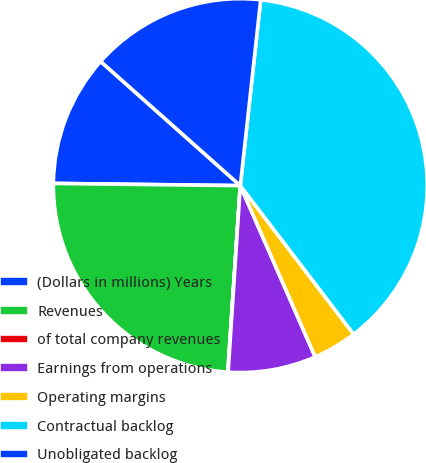Convert chart to OTSL. <chart><loc_0><loc_0><loc_500><loc_500><pie_chart><fcel>(Dollars in millions) Years<fcel>Revenues<fcel>of total company revenues<fcel>Earnings from operations<fcel>Operating margins<fcel>Contractual backlog<fcel>Unobligated backlog<nl><fcel>11.38%<fcel>24.12%<fcel>0.03%<fcel>7.6%<fcel>3.81%<fcel>37.89%<fcel>15.17%<nl></chart> 